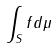<formula> <loc_0><loc_0><loc_500><loc_500>\int _ { S } f d \mu</formula> 